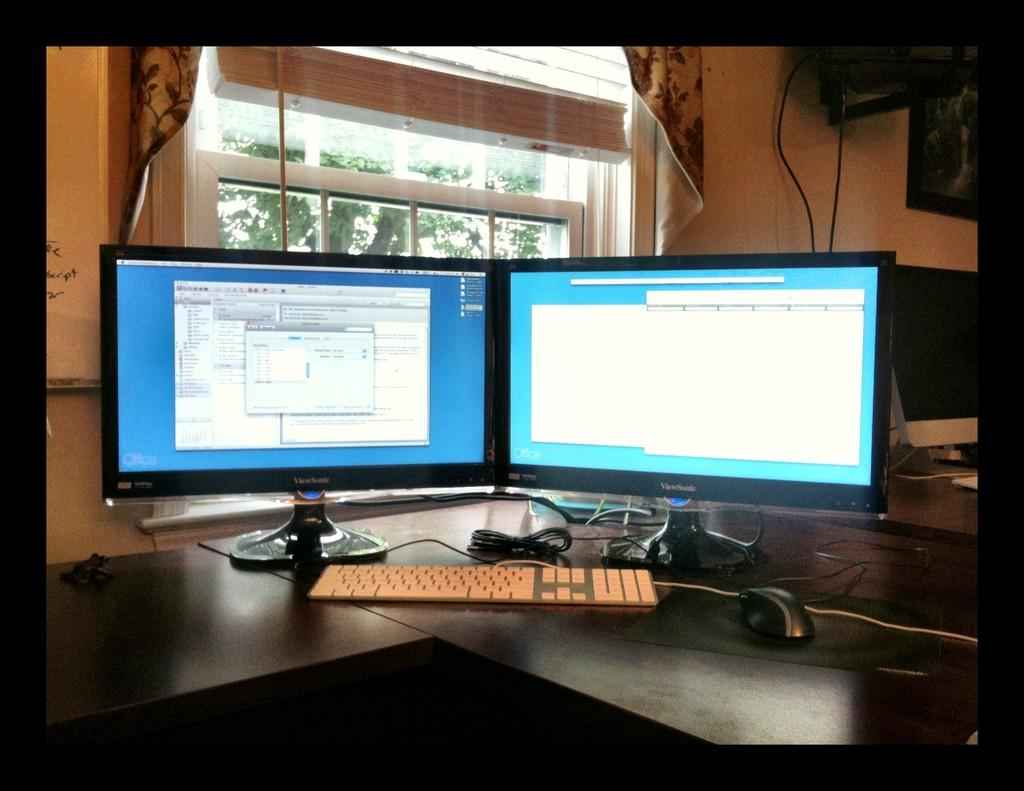Provide a one-sentence caption for the provided image. A pair of Viewsonic monitors sitting on top of a dark wood corner desk. 